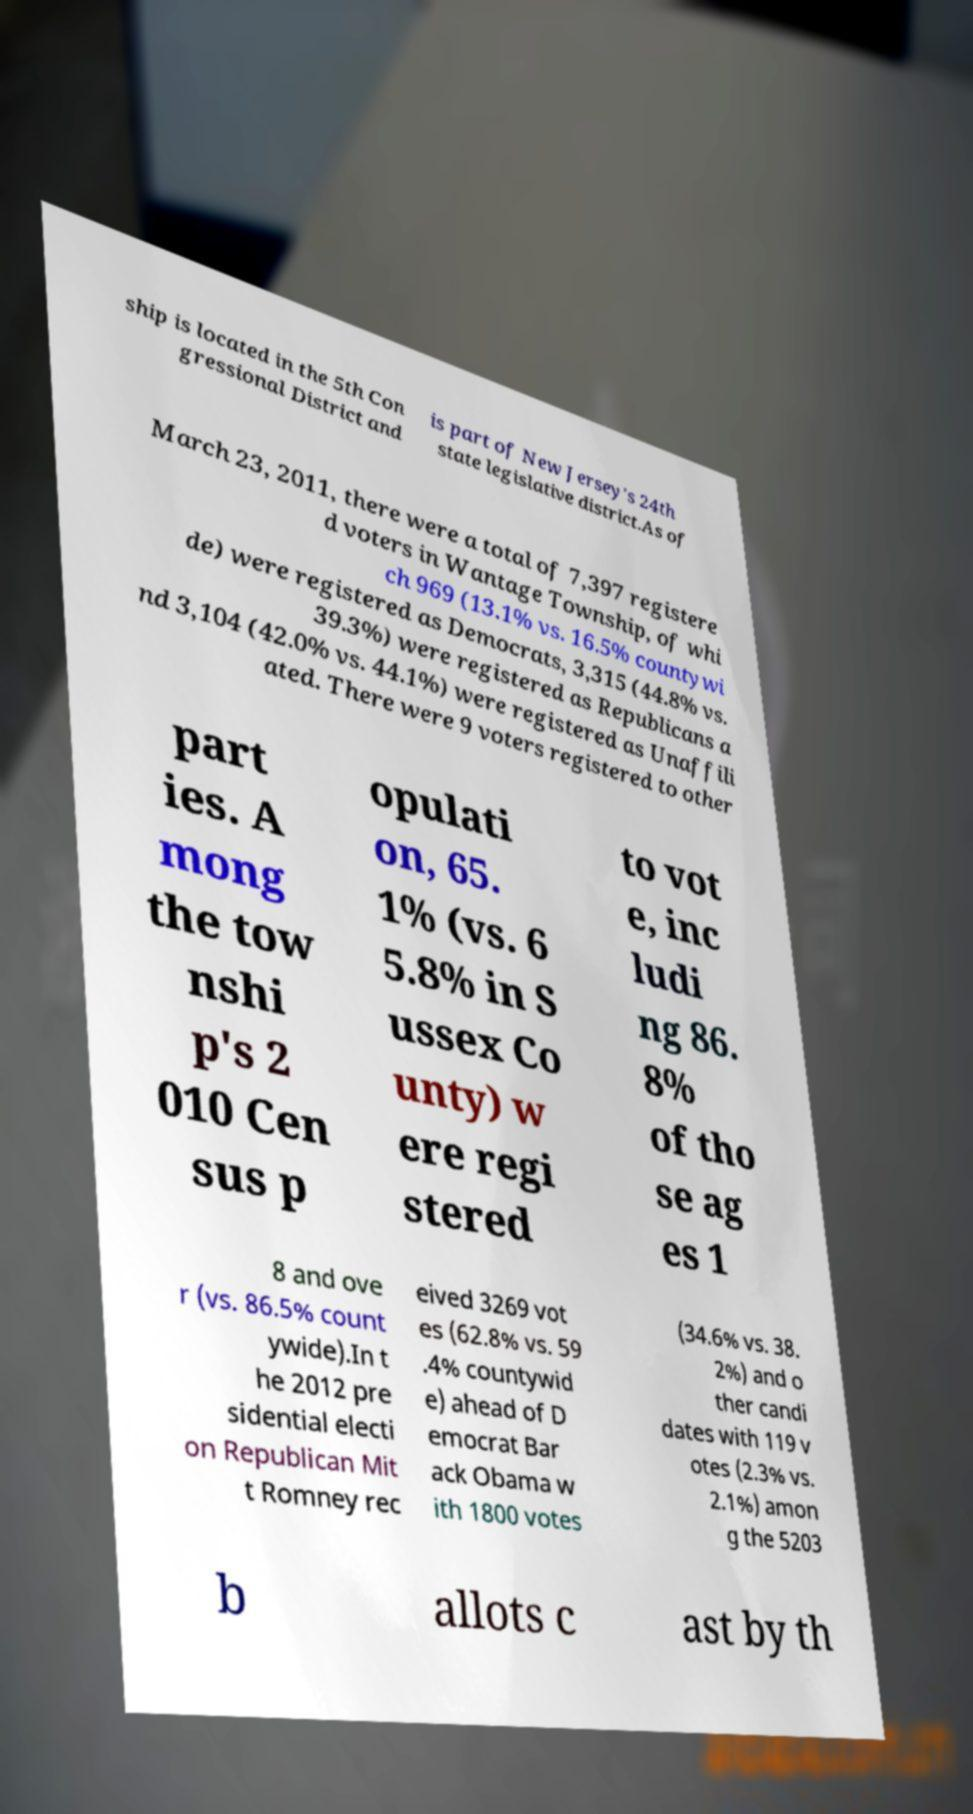Can you read and provide the text displayed in the image?This photo seems to have some interesting text. Can you extract and type it out for me? ship is located in the 5th Con gressional District and is part of New Jersey's 24th state legislative district.As of March 23, 2011, there were a total of 7,397 registere d voters in Wantage Township, of whi ch 969 (13.1% vs. 16.5% countywi de) were registered as Democrats, 3,315 (44.8% vs. 39.3%) were registered as Republicans a nd 3,104 (42.0% vs. 44.1%) were registered as Unaffili ated. There were 9 voters registered to other part ies. A mong the tow nshi p's 2 010 Cen sus p opulati on, 65. 1% (vs. 6 5.8% in S ussex Co unty) w ere regi stered to vot e, inc ludi ng 86. 8% of tho se ag es 1 8 and ove r (vs. 86.5% count ywide).In t he 2012 pre sidential electi on Republican Mit t Romney rec eived 3269 vot es (62.8% vs. 59 .4% countywid e) ahead of D emocrat Bar ack Obama w ith 1800 votes (34.6% vs. 38. 2%) and o ther candi dates with 119 v otes (2.3% vs. 2.1%) amon g the 5203 b allots c ast by th 